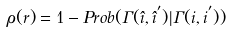Convert formula to latex. <formula><loc_0><loc_0><loc_500><loc_500>\rho ( r ) = 1 - P r o b ( \Gamma ( \hat { i } , \hat { i } ^ { ^ { \prime } } ) | \Gamma ( i , i ^ { ^ { \prime } } ) )</formula> 